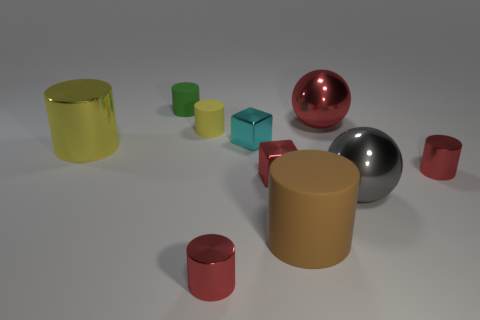How many red cylinders must be subtracted to get 1 red cylinders? 1 Subtract all red metallic cylinders. How many cylinders are left? 4 Subtract 1 balls. How many balls are left? 1 Subtract all green balls. How many yellow cylinders are left? 2 Subtract all balls. How many objects are left? 8 Subtract all red balls. How many balls are left? 1 Subtract all tiny cyan metal objects. Subtract all big cyan metallic cubes. How many objects are left? 9 Add 2 cyan metallic blocks. How many cyan metallic blocks are left? 3 Add 8 large red shiny objects. How many large red shiny objects exist? 9 Subtract 0 purple cylinders. How many objects are left? 10 